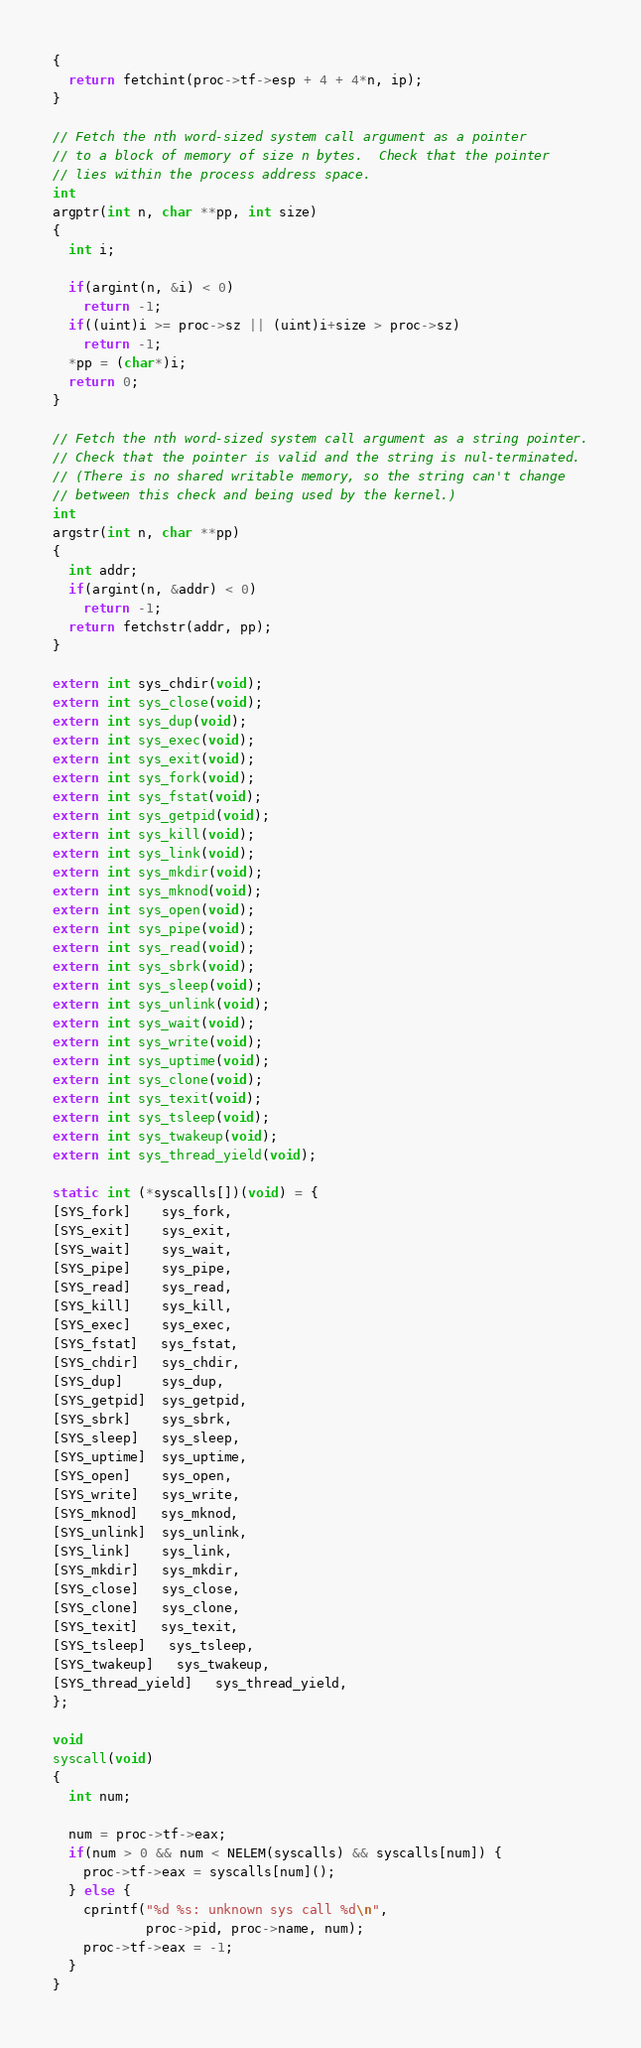<code> <loc_0><loc_0><loc_500><loc_500><_C_>{
  return fetchint(proc->tf->esp + 4 + 4*n, ip);
}

// Fetch the nth word-sized system call argument as a pointer
// to a block of memory of size n bytes.  Check that the pointer
// lies within the process address space.
int
argptr(int n, char **pp, int size)
{
  int i;
  
  if(argint(n, &i) < 0)
    return -1;
  if((uint)i >= proc->sz || (uint)i+size > proc->sz)
    return -1;
  *pp = (char*)i;
  return 0;
}

// Fetch the nth word-sized system call argument as a string pointer.
// Check that the pointer is valid and the string is nul-terminated.
// (There is no shared writable memory, so the string can't change
// between this check and being used by the kernel.)
int
argstr(int n, char **pp)
{
  int addr;
  if(argint(n, &addr) < 0)
    return -1;
  return fetchstr(addr, pp);
}

extern int sys_chdir(void);
extern int sys_close(void);
extern int sys_dup(void);
extern int sys_exec(void);
extern int sys_exit(void);
extern int sys_fork(void);
extern int sys_fstat(void);
extern int sys_getpid(void);
extern int sys_kill(void);
extern int sys_link(void);
extern int sys_mkdir(void);
extern int sys_mknod(void);
extern int sys_open(void);
extern int sys_pipe(void);
extern int sys_read(void);
extern int sys_sbrk(void);
extern int sys_sleep(void);
extern int sys_unlink(void);
extern int sys_wait(void);
extern int sys_write(void);
extern int sys_uptime(void);
extern int sys_clone(void);
extern int sys_texit(void);
extern int sys_tsleep(void);
extern int sys_twakeup(void);
extern int sys_thread_yield(void);

static int (*syscalls[])(void) = {
[SYS_fork]    sys_fork,
[SYS_exit]    sys_exit,
[SYS_wait]    sys_wait,
[SYS_pipe]    sys_pipe,
[SYS_read]    sys_read,
[SYS_kill]    sys_kill,
[SYS_exec]    sys_exec,
[SYS_fstat]   sys_fstat,
[SYS_chdir]   sys_chdir,
[SYS_dup]     sys_dup,
[SYS_getpid]  sys_getpid,
[SYS_sbrk]    sys_sbrk,
[SYS_sleep]   sys_sleep,
[SYS_uptime]  sys_uptime,
[SYS_open]    sys_open,
[SYS_write]   sys_write,
[SYS_mknod]   sys_mknod,
[SYS_unlink]  sys_unlink,
[SYS_link]    sys_link,
[SYS_mkdir]   sys_mkdir,
[SYS_close]   sys_close,
[SYS_clone]   sys_clone,
[SYS_texit]   sys_texit,
[SYS_tsleep]   sys_tsleep,
[SYS_twakeup]   sys_twakeup,
[SYS_thread_yield]   sys_thread_yield, 
};

void
syscall(void)
{
  int num;

  num = proc->tf->eax;
  if(num > 0 && num < NELEM(syscalls) && syscalls[num]) {
    proc->tf->eax = syscalls[num]();
  } else {
    cprintf("%d %s: unknown sys call %d\n",
            proc->pid, proc->name, num);
    proc->tf->eax = -1;
  }
}
</code> 